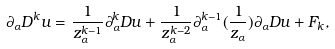Convert formula to latex. <formula><loc_0><loc_0><loc_500><loc_500>\partial _ { \alpha } D ^ { k } u = \frac { 1 } { z _ { \alpha } ^ { k - 1 } } \partial _ { \alpha } ^ { k } D u + \frac { 1 } { z _ { \alpha } ^ { k - 2 } } \partial _ { \alpha } ^ { k - 1 } ( \frac { 1 } { z _ { \alpha } } ) \partial _ { \alpha } D u + F _ { k } ,</formula> 